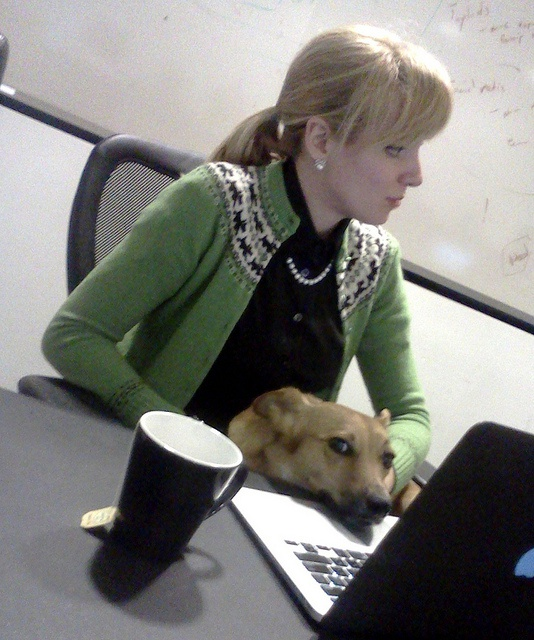Describe the objects in this image and their specific colors. I can see people in darkgray, black, gray, and darkgreen tones, dining table in darkgray and gray tones, dog in darkgray, gray, black, and tan tones, laptop in darkgray, white, black, and gray tones, and cup in darkgray, black, ivory, and gray tones in this image. 